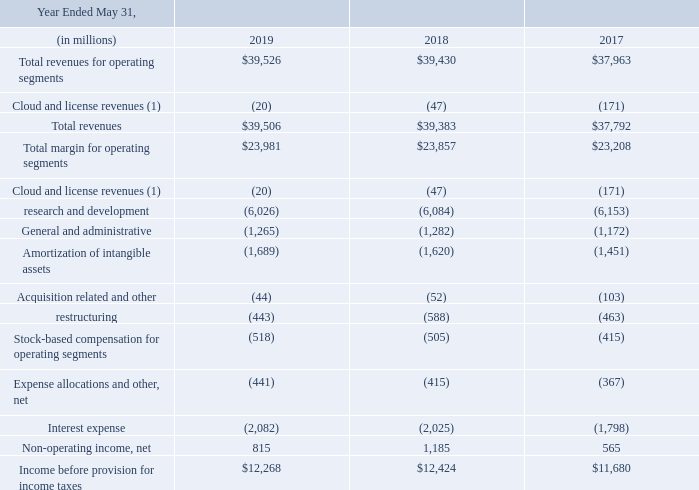The following tabl e reconciles total operating segment revenues to total revenues as well as total operating segment margin to income before provision for income taxes:
(1) Cloud and license revenues presented for management reporting included revenues related to cloud and license obligations that would have otherwise been recorded by the acquired businesses as independent entities but were not recognized in our consolidated statements of operations for the periods presented due to business combination accounting requirements. See Note 9 for an explanation of these adjustments and this table for a reconciliation of our total operating segment revenues to our total revenues as reported in our consolidated statements of operations.
How much was the research and development and restructuring expenses in 2019?
Answer scale should be: million. 6,026+443 
Answer: 6469. How much was the percentage change in total revenues from 2017 to 2019?
Answer scale should be: percent. (39,506-37,792)/37,792 
Answer: 4.54. How much more was spent on interest expense than on stock-based compensation for operating segments in 2018?
Answer scale should be: million. 2,025-505 
Answer: 1520. Which month was the financial year end? May. Does the values in the table represent values before or after provision of income taxes? The following tabl e reconciles total operating segment revenues to total revenues as well as total operating segment margin to income before provision for income taxes. What was the amortization of intangible assets for 2019 and 2017?
Answer scale should be: million. 1,689, 1,451. 